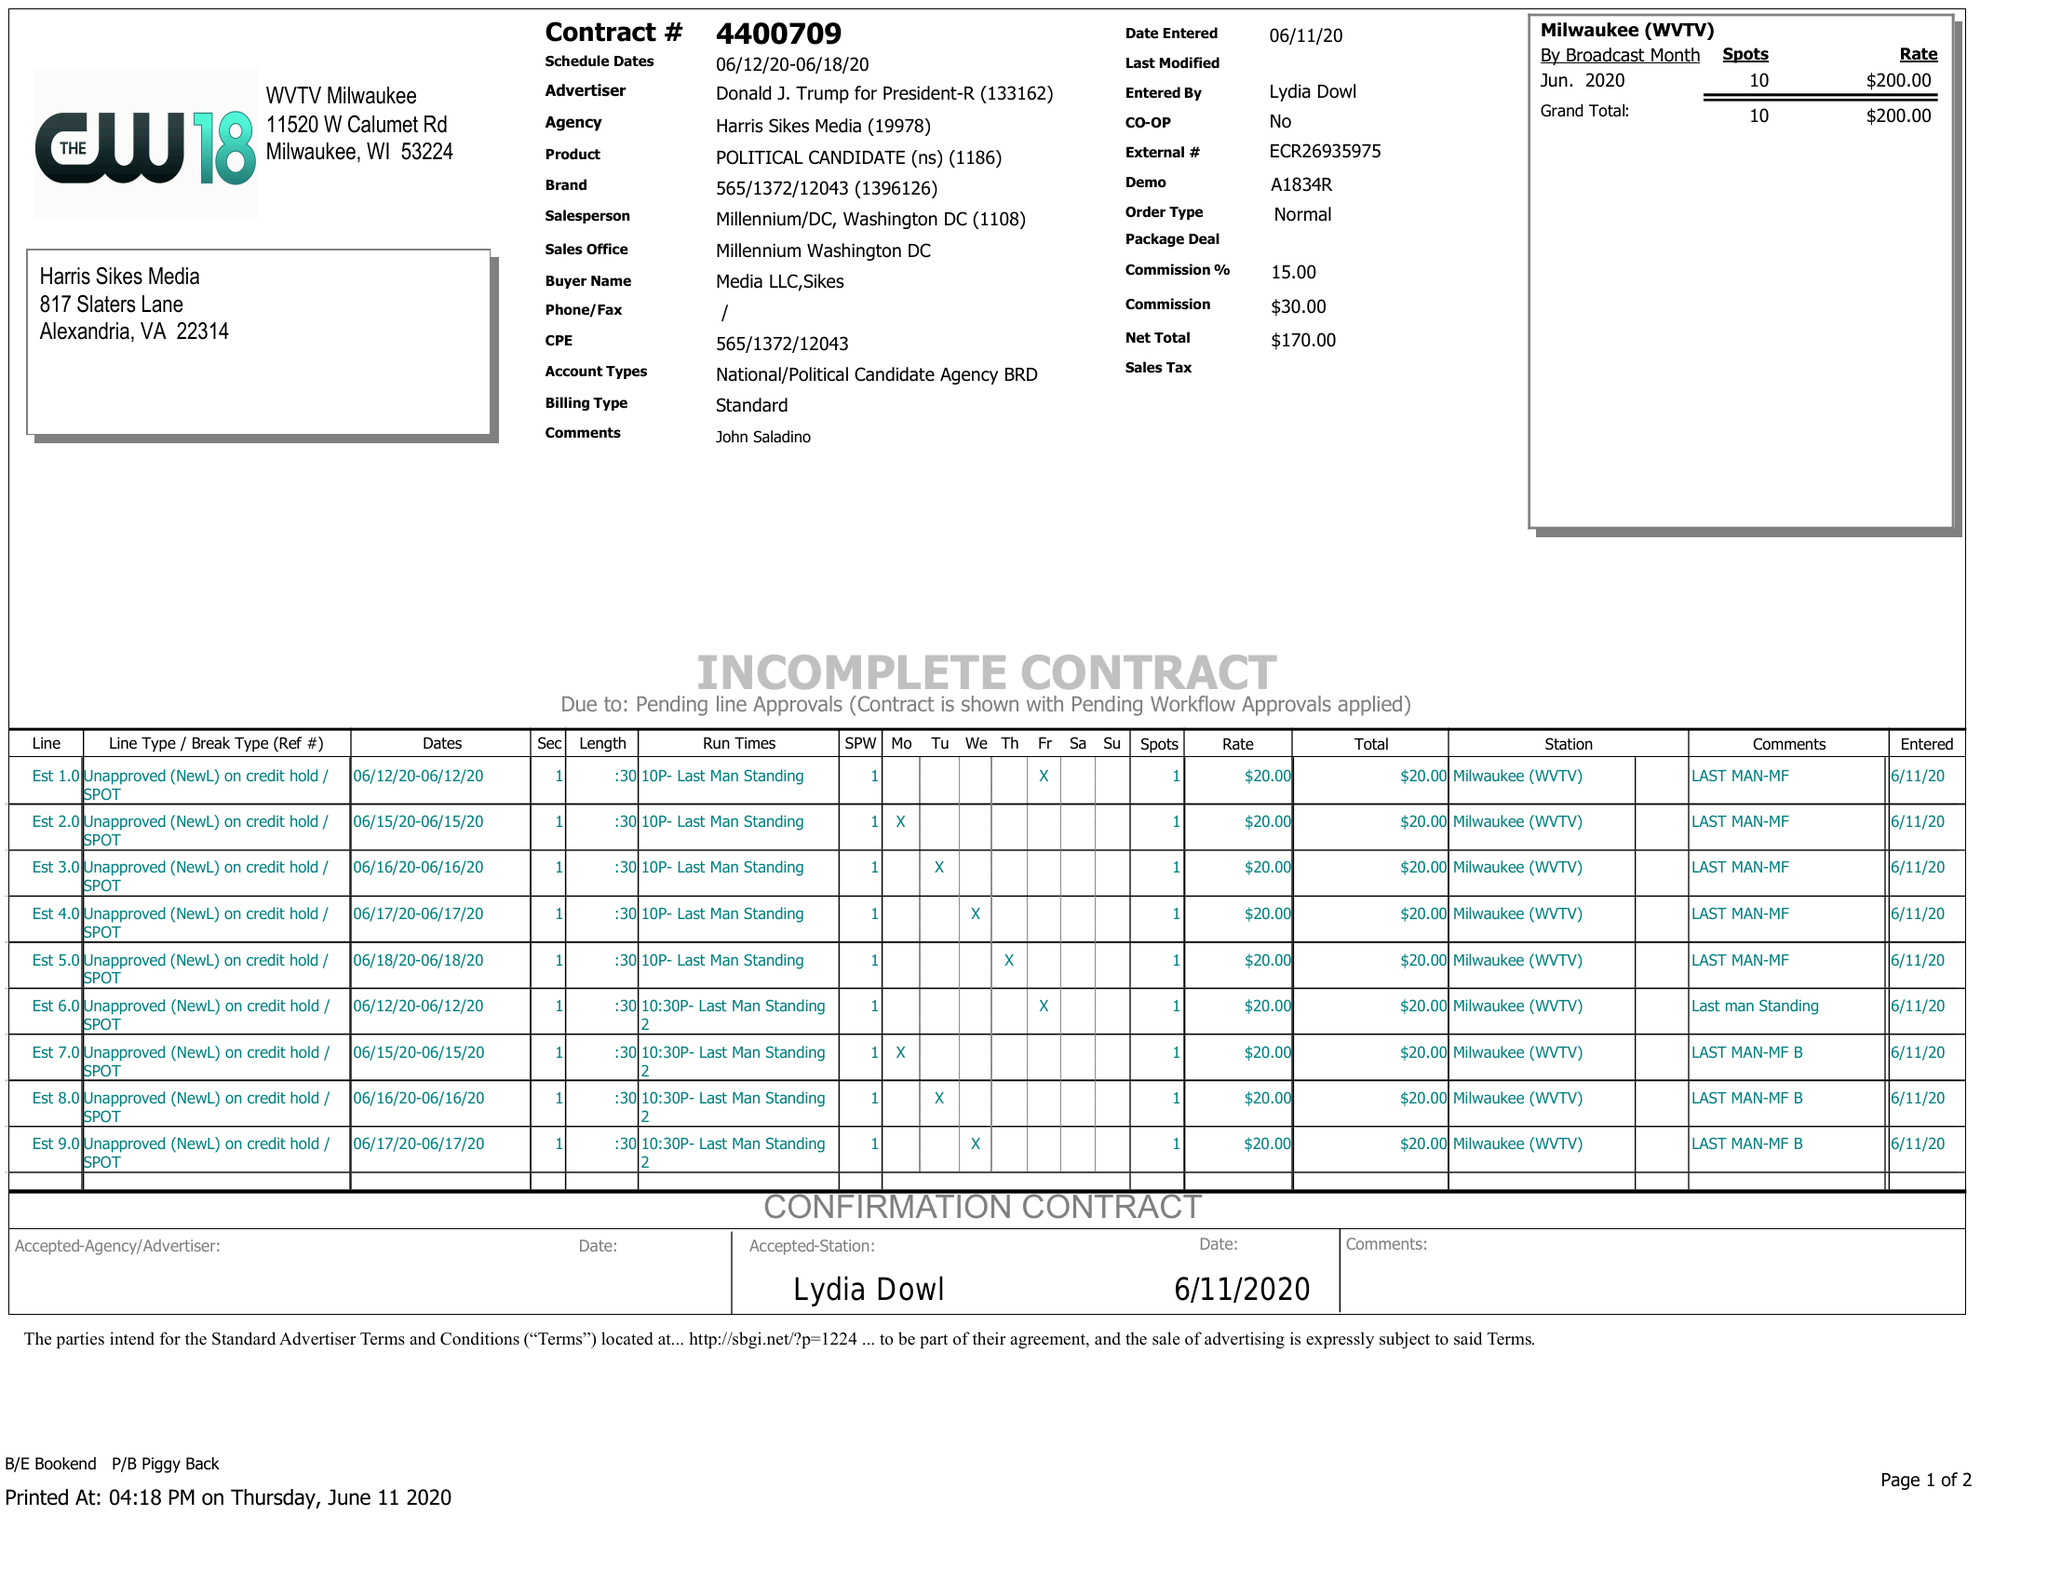What is the value for the flight_from?
Answer the question using a single word or phrase. 06/12/20 